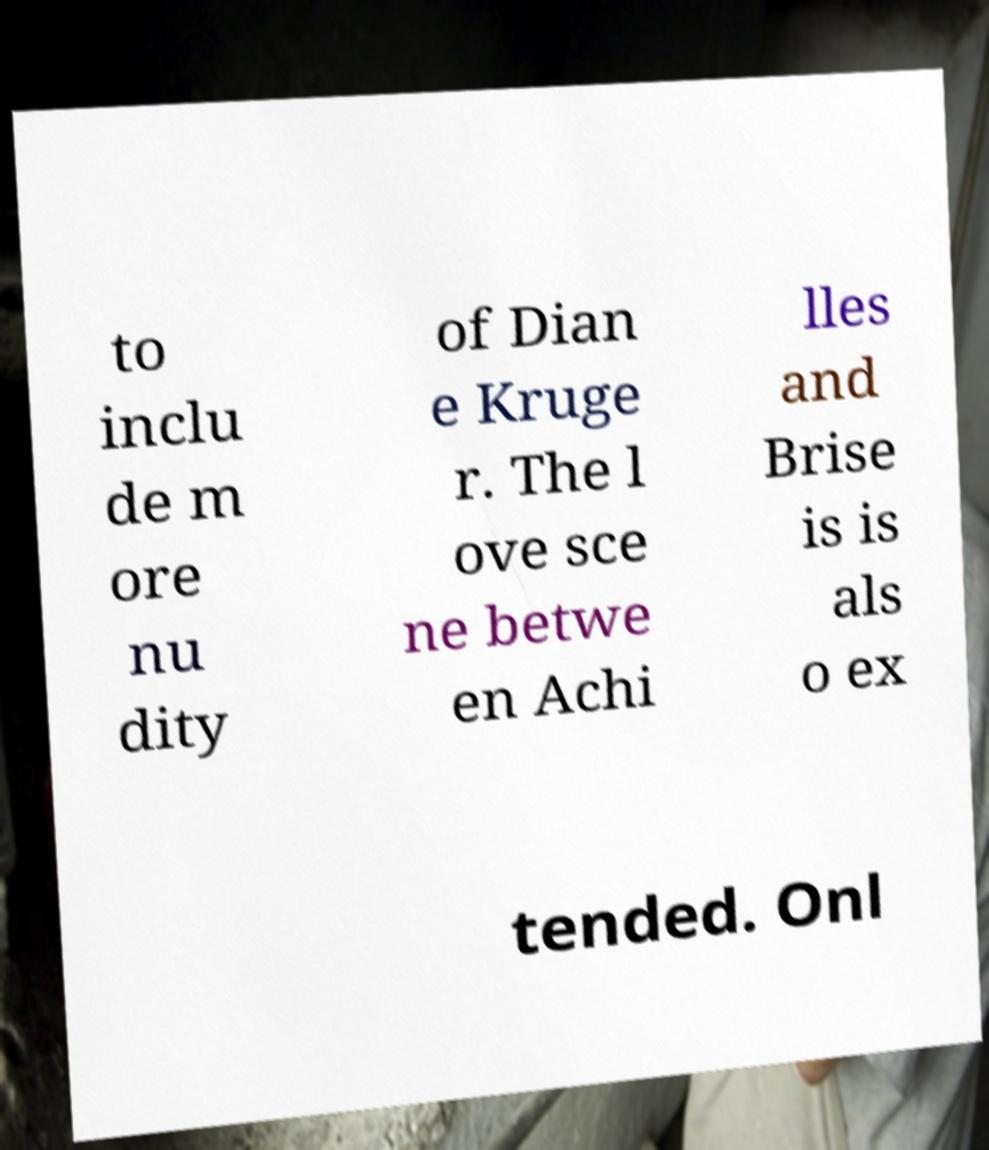Can you read and provide the text displayed in the image?This photo seems to have some interesting text. Can you extract and type it out for me? to inclu de m ore nu dity of Dian e Kruge r. The l ove sce ne betwe en Achi lles and Brise is is als o ex tended. Onl 